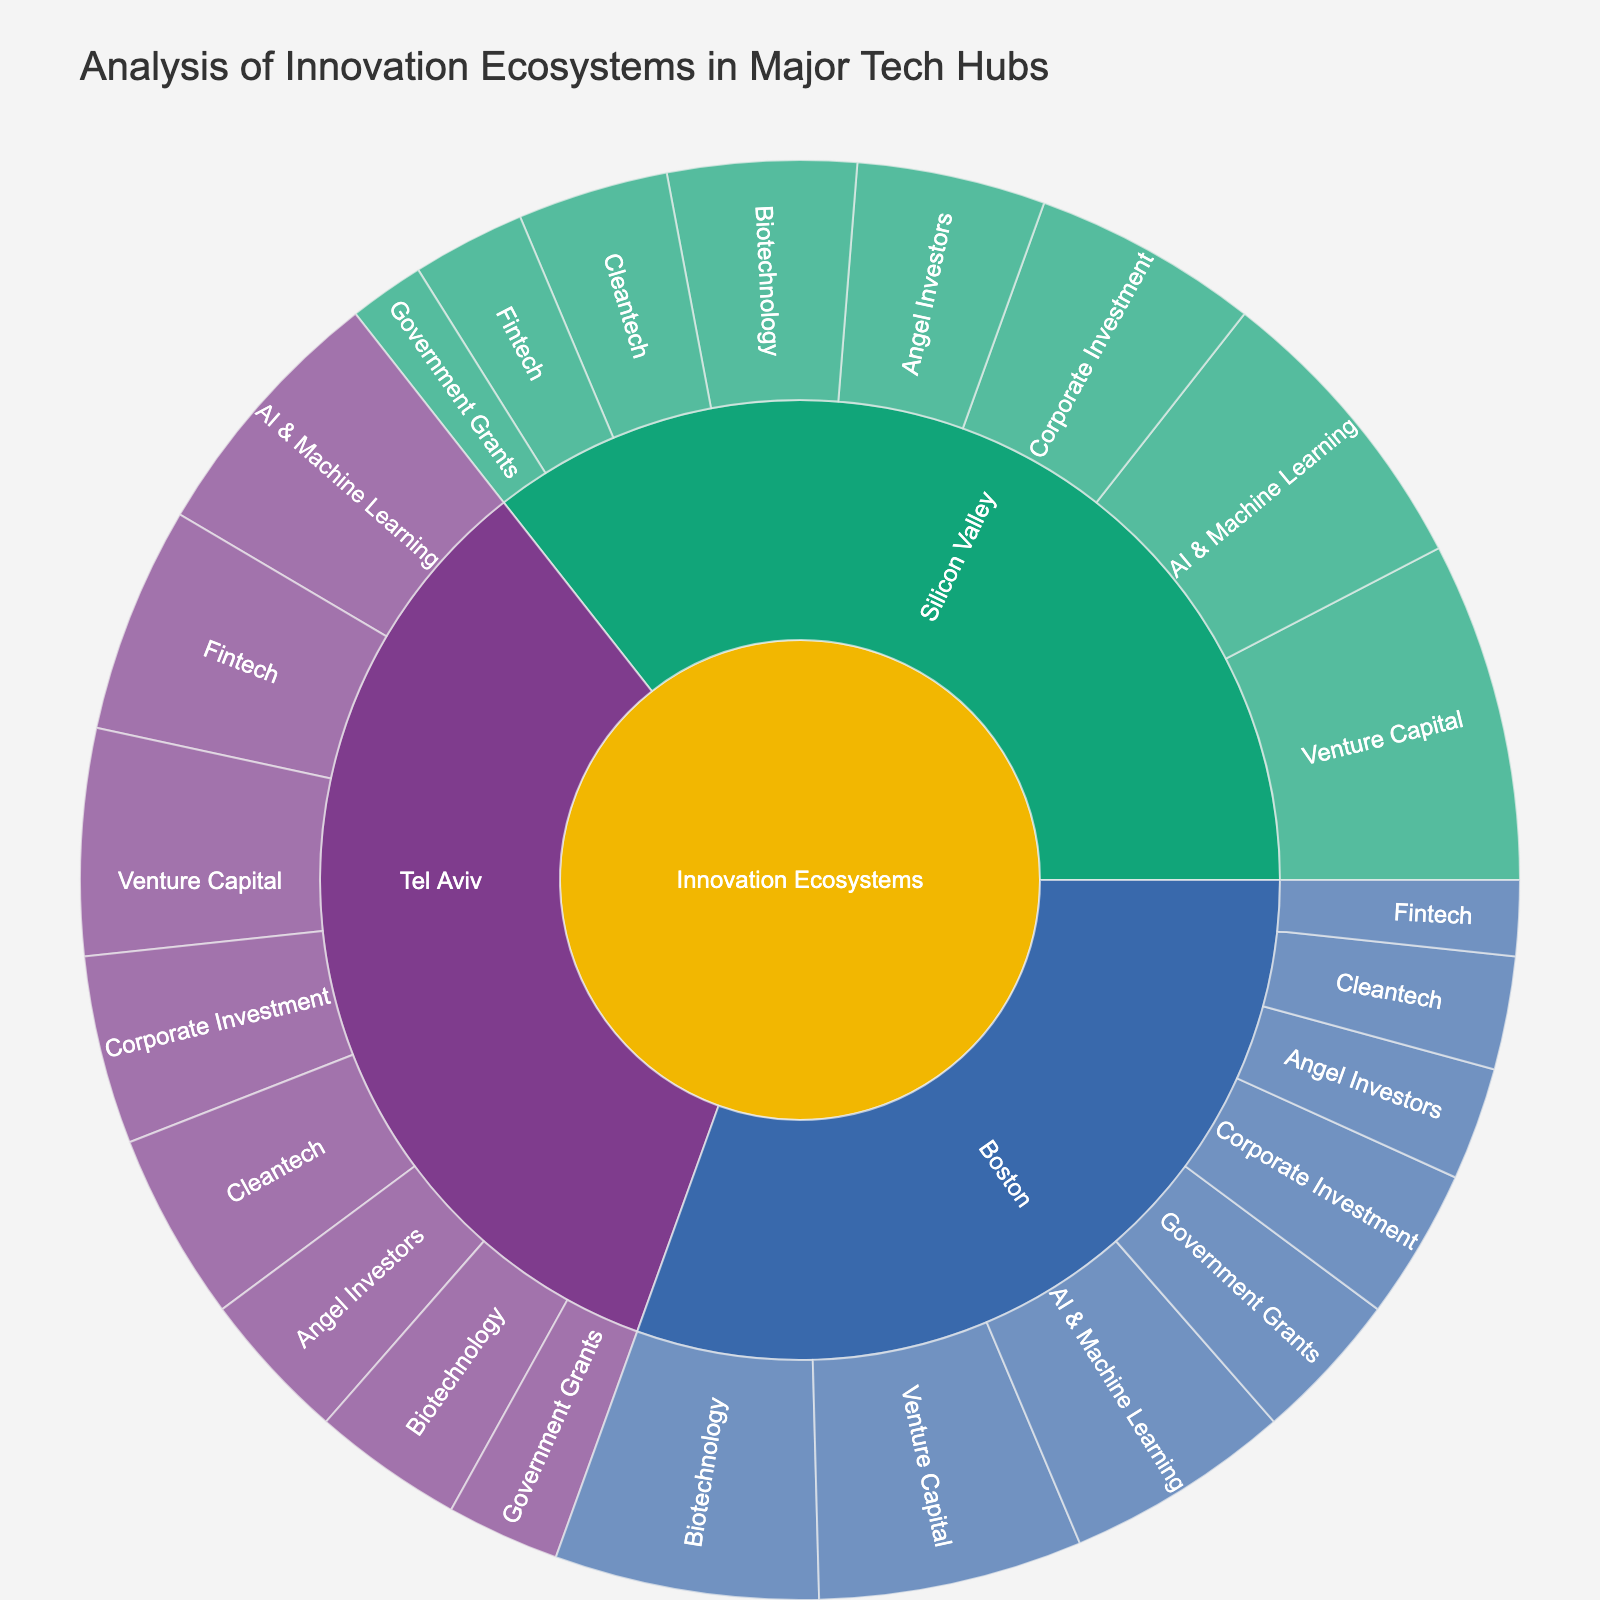How many main categories are represented in the plot? The innermost layer of the Sunburst Plot shows the main categories. There are three categories: Silicon Valley, Boston, and Tel Aviv.
Answer: Three Which city has the highest overall investment from venture capital? Summing up the values for venture capital investments across the three cities, we find: Silicon Valley (45), Boston (35), and Tel Aviv (30). Silicon Valley has the highest total with 45 units.
Answer: Silicon Valley What is the total amount of funding for government grants across all cities? To find the total, sum the values for government grants in each city: Silicon Valley (10) + Boston (20) + Tel Aviv (15) = 45.
Answer: 45 Compare the funding from corporate investment between Silicon Valley and Tel Aviv. Which city has more, and by how much? Silicon Valley has 30 units from corporate investment while Tel Aviv has 25 units. The difference is 30 - 25 = 5 units.
Answer: Silicon Valley by 5 Which industry focus in Silicon Valley receives the least funding? In Silicon Valley, the funding amounts for industry focuses are: AI & Machine Learning (40), Biotechnology (25), Cleantech (20), Fintech (15). The least funding goes to Fintech with 15 units.
Answer: Fintech What's the combined funding value for AI & Machine Learning across all cities? Summing AI & Machine Learning funding for each city: Silicon Valley (40) + Boston (30) + Tel Aviv (35) = 105
Answer: 105 How does the funding in Biotechnology compare between Boston and Tel Aviv? Boston has 35 units of funding in Biotechnology, while Tel Aviv has 20 units. Boston receives 15 more units than Tel Aviv.
Answer: Boston has 15 more units than Tel Aviv Among all categories and subcategories combined, which funding source has the highest value? The highest funding value across all categories and subcategories is Venture Capital in Silicon Valley with 45 units.
Answer: Venture Capital in Silicon Valley What is the total investment received by Cleantech industry across all tech hubs? Summing Cleantech investments: Silicon Valley (20) + Boston (15) + Tel Aviv (25) = 60
Answer: 60 